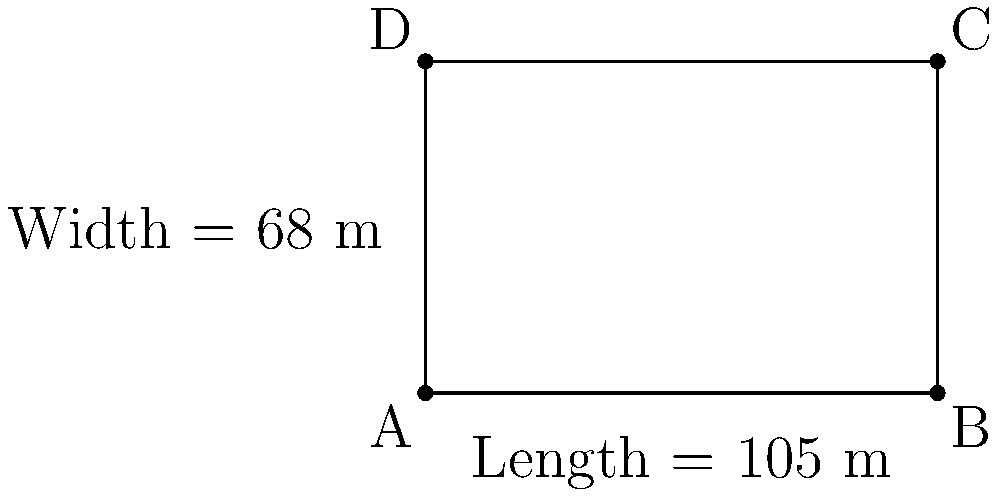Khalil Bader's favorite soccer field has dimensions as shown in the diagram. Calculate the perimeter of this field, which represents the total distance he would run if he were to jog around the entire field once. Express your answer in meters. To calculate the perimeter of the soccer field, we need to add up the lengths of all four sides. Let's break it down step-by-step:

1. Identify the length and width of the field:
   Length = 105 m
   Width = 68 m

2. The perimeter of a rectangle is given by the formula:
   $$ P = 2l + 2w $$
   Where $P$ is the perimeter, $l$ is the length, and $w$ is the width.

3. Substitute the values into the formula:
   $$ P = 2(105) + 2(68) $$

4. Multiply:
   $$ P = 210 + 136 $$

5. Add the results:
   $$ P = 346 $$

Therefore, the perimeter of the soccer field is 346 meters.
Answer: 346 m 